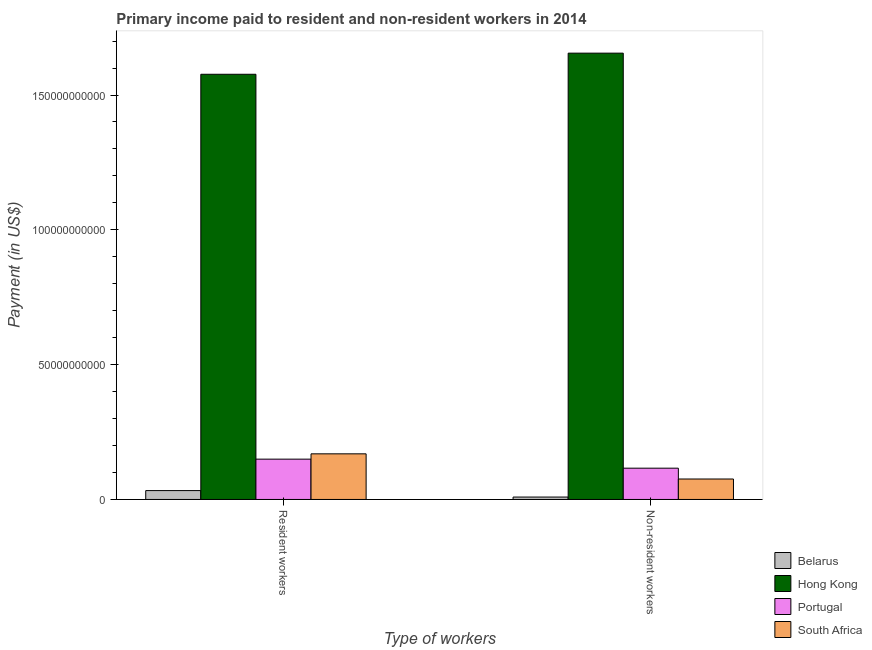How many different coloured bars are there?
Your answer should be very brief. 4. Are the number of bars per tick equal to the number of legend labels?
Keep it short and to the point. Yes. How many bars are there on the 2nd tick from the left?
Make the answer very short. 4. What is the label of the 1st group of bars from the left?
Your answer should be compact. Resident workers. What is the payment made to resident workers in Portugal?
Provide a succinct answer. 1.50e+1. Across all countries, what is the maximum payment made to non-resident workers?
Offer a terse response. 1.66e+11. Across all countries, what is the minimum payment made to resident workers?
Make the answer very short. 3.29e+09. In which country was the payment made to resident workers maximum?
Provide a succinct answer. Hong Kong. In which country was the payment made to non-resident workers minimum?
Your answer should be very brief. Belarus. What is the total payment made to non-resident workers in the graph?
Provide a succinct answer. 1.86e+11. What is the difference between the payment made to resident workers in Hong Kong and that in Portugal?
Your answer should be very brief. 1.43e+11. What is the difference between the payment made to resident workers in Belarus and the payment made to non-resident workers in South Africa?
Keep it short and to the point. -4.29e+09. What is the average payment made to non-resident workers per country?
Your response must be concise. 4.64e+1. What is the difference between the payment made to non-resident workers and payment made to resident workers in Portugal?
Give a very brief answer. -3.35e+09. In how many countries, is the payment made to non-resident workers greater than 140000000000 US$?
Make the answer very short. 1. What is the ratio of the payment made to resident workers in Portugal to that in Belarus?
Ensure brevity in your answer.  4.54. Is the payment made to resident workers in South Africa less than that in Portugal?
Provide a succinct answer. No. What does the 1st bar from the left in Resident workers represents?
Offer a very short reply. Belarus. What does the 2nd bar from the right in Non-resident workers represents?
Offer a very short reply. Portugal. Are all the bars in the graph horizontal?
Provide a short and direct response. No. How many countries are there in the graph?
Your answer should be compact. 4. Does the graph contain grids?
Give a very brief answer. No. How are the legend labels stacked?
Your response must be concise. Vertical. What is the title of the graph?
Your answer should be very brief. Primary income paid to resident and non-resident workers in 2014. What is the label or title of the X-axis?
Your answer should be very brief. Type of workers. What is the label or title of the Y-axis?
Ensure brevity in your answer.  Payment (in US$). What is the Payment (in US$) of Belarus in Resident workers?
Make the answer very short. 3.29e+09. What is the Payment (in US$) in Hong Kong in Resident workers?
Your answer should be compact. 1.58e+11. What is the Payment (in US$) in Portugal in Resident workers?
Your answer should be compact. 1.50e+1. What is the Payment (in US$) in South Africa in Resident workers?
Your answer should be compact. 1.69e+1. What is the Payment (in US$) of Belarus in Non-resident workers?
Provide a short and direct response. 8.92e+08. What is the Payment (in US$) in Hong Kong in Non-resident workers?
Your answer should be very brief. 1.66e+11. What is the Payment (in US$) in Portugal in Non-resident workers?
Offer a terse response. 1.16e+1. What is the Payment (in US$) in South Africa in Non-resident workers?
Give a very brief answer. 7.58e+09. Across all Type of workers, what is the maximum Payment (in US$) in Belarus?
Your answer should be compact. 3.29e+09. Across all Type of workers, what is the maximum Payment (in US$) of Hong Kong?
Offer a very short reply. 1.66e+11. Across all Type of workers, what is the maximum Payment (in US$) in Portugal?
Give a very brief answer. 1.50e+1. Across all Type of workers, what is the maximum Payment (in US$) in South Africa?
Your answer should be compact. 1.69e+1. Across all Type of workers, what is the minimum Payment (in US$) of Belarus?
Your answer should be compact. 8.92e+08. Across all Type of workers, what is the minimum Payment (in US$) of Hong Kong?
Provide a short and direct response. 1.58e+11. Across all Type of workers, what is the minimum Payment (in US$) of Portugal?
Your answer should be compact. 1.16e+1. Across all Type of workers, what is the minimum Payment (in US$) of South Africa?
Your answer should be very brief. 7.58e+09. What is the total Payment (in US$) of Belarus in the graph?
Offer a very short reply. 4.18e+09. What is the total Payment (in US$) of Hong Kong in the graph?
Your answer should be compact. 3.23e+11. What is the total Payment (in US$) of Portugal in the graph?
Make the answer very short. 2.66e+1. What is the total Payment (in US$) in South Africa in the graph?
Offer a terse response. 2.45e+1. What is the difference between the Payment (in US$) of Belarus in Resident workers and that in Non-resident workers?
Provide a succinct answer. 2.40e+09. What is the difference between the Payment (in US$) in Hong Kong in Resident workers and that in Non-resident workers?
Ensure brevity in your answer.  -7.84e+09. What is the difference between the Payment (in US$) in Portugal in Resident workers and that in Non-resident workers?
Ensure brevity in your answer.  3.35e+09. What is the difference between the Payment (in US$) in South Africa in Resident workers and that in Non-resident workers?
Your response must be concise. 9.34e+09. What is the difference between the Payment (in US$) of Belarus in Resident workers and the Payment (in US$) of Hong Kong in Non-resident workers?
Offer a very short reply. -1.62e+11. What is the difference between the Payment (in US$) of Belarus in Resident workers and the Payment (in US$) of Portugal in Non-resident workers?
Your answer should be compact. -8.31e+09. What is the difference between the Payment (in US$) of Belarus in Resident workers and the Payment (in US$) of South Africa in Non-resident workers?
Your response must be concise. -4.29e+09. What is the difference between the Payment (in US$) of Hong Kong in Resident workers and the Payment (in US$) of Portugal in Non-resident workers?
Your answer should be very brief. 1.46e+11. What is the difference between the Payment (in US$) in Hong Kong in Resident workers and the Payment (in US$) in South Africa in Non-resident workers?
Offer a very short reply. 1.50e+11. What is the difference between the Payment (in US$) in Portugal in Resident workers and the Payment (in US$) in South Africa in Non-resident workers?
Provide a succinct answer. 7.37e+09. What is the average Payment (in US$) in Belarus per Type of workers?
Ensure brevity in your answer.  2.09e+09. What is the average Payment (in US$) of Hong Kong per Type of workers?
Your response must be concise. 1.62e+11. What is the average Payment (in US$) in Portugal per Type of workers?
Keep it short and to the point. 1.33e+1. What is the average Payment (in US$) of South Africa per Type of workers?
Make the answer very short. 1.23e+1. What is the difference between the Payment (in US$) of Belarus and Payment (in US$) of Hong Kong in Resident workers?
Offer a very short reply. -1.54e+11. What is the difference between the Payment (in US$) of Belarus and Payment (in US$) of Portugal in Resident workers?
Make the answer very short. -1.17e+1. What is the difference between the Payment (in US$) of Belarus and Payment (in US$) of South Africa in Resident workers?
Offer a very short reply. -1.36e+1. What is the difference between the Payment (in US$) in Hong Kong and Payment (in US$) in Portugal in Resident workers?
Keep it short and to the point. 1.43e+11. What is the difference between the Payment (in US$) in Hong Kong and Payment (in US$) in South Africa in Resident workers?
Your answer should be compact. 1.41e+11. What is the difference between the Payment (in US$) in Portugal and Payment (in US$) in South Africa in Resident workers?
Provide a short and direct response. -1.97e+09. What is the difference between the Payment (in US$) of Belarus and Payment (in US$) of Hong Kong in Non-resident workers?
Ensure brevity in your answer.  -1.65e+11. What is the difference between the Payment (in US$) in Belarus and Payment (in US$) in Portugal in Non-resident workers?
Your answer should be very brief. -1.07e+1. What is the difference between the Payment (in US$) in Belarus and Payment (in US$) in South Africa in Non-resident workers?
Give a very brief answer. -6.69e+09. What is the difference between the Payment (in US$) in Hong Kong and Payment (in US$) in Portugal in Non-resident workers?
Provide a succinct answer. 1.54e+11. What is the difference between the Payment (in US$) of Hong Kong and Payment (in US$) of South Africa in Non-resident workers?
Offer a terse response. 1.58e+11. What is the difference between the Payment (in US$) of Portugal and Payment (in US$) of South Africa in Non-resident workers?
Your answer should be compact. 4.02e+09. What is the ratio of the Payment (in US$) of Belarus in Resident workers to that in Non-resident workers?
Provide a succinct answer. 3.69. What is the ratio of the Payment (in US$) in Hong Kong in Resident workers to that in Non-resident workers?
Ensure brevity in your answer.  0.95. What is the ratio of the Payment (in US$) of Portugal in Resident workers to that in Non-resident workers?
Your answer should be compact. 1.29. What is the ratio of the Payment (in US$) of South Africa in Resident workers to that in Non-resident workers?
Offer a very short reply. 2.23. What is the difference between the highest and the second highest Payment (in US$) of Belarus?
Offer a very short reply. 2.40e+09. What is the difference between the highest and the second highest Payment (in US$) in Hong Kong?
Make the answer very short. 7.84e+09. What is the difference between the highest and the second highest Payment (in US$) in Portugal?
Provide a succinct answer. 3.35e+09. What is the difference between the highest and the second highest Payment (in US$) of South Africa?
Your response must be concise. 9.34e+09. What is the difference between the highest and the lowest Payment (in US$) in Belarus?
Provide a succinct answer. 2.40e+09. What is the difference between the highest and the lowest Payment (in US$) in Hong Kong?
Your answer should be compact. 7.84e+09. What is the difference between the highest and the lowest Payment (in US$) in Portugal?
Your answer should be compact. 3.35e+09. What is the difference between the highest and the lowest Payment (in US$) in South Africa?
Keep it short and to the point. 9.34e+09. 